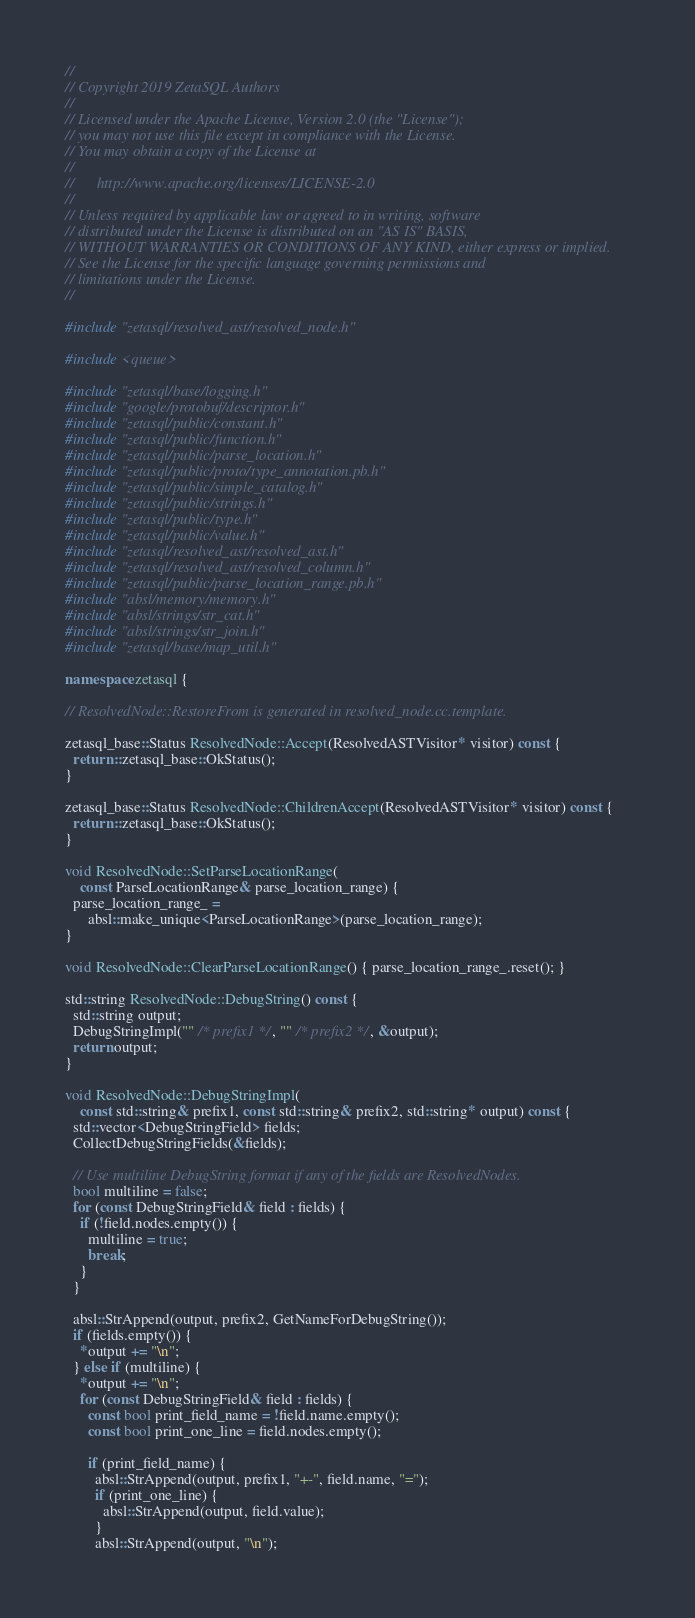<code> <loc_0><loc_0><loc_500><loc_500><_C++_>//
// Copyright 2019 ZetaSQL Authors
//
// Licensed under the Apache License, Version 2.0 (the "License");
// you may not use this file except in compliance with the License.
// You may obtain a copy of the License at
//
//      http://www.apache.org/licenses/LICENSE-2.0
//
// Unless required by applicable law or agreed to in writing, software
// distributed under the License is distributed on an "AS IS" BASIS,
// WITHOUT WARRANTIES OR CONDITIONS OF ANY KIND, either express or implied.
// See the License for the specific language governing permissions and
// limitations under the License.
//

#include "zetasql/resolved_ast/resolved_node.h"

#include <queue>

#include "zetasql/base/logging.h"
#include "google/protobuf/descriptor.h"
#include "zetasql/public/constant.h"
#include "zetasql/public/function.h"
#include "zetasql/public/parse_location.h"
#include "zetasql/public/proto/type_annotation.pb.h"
#include "zetasql/public/simple_catalog.h"
#include "zetasql/public/strings.h"
#include "zetasql/public/type.h"
#include "zetasql/public/value.h"
#include "zetasql/resolved_ast/resolved_ast.h"
#include "zetasql/resolved_ast/resolved_column.h"
#include "zetasql/public/parse_location_range.pb.h"
#include "absl/memory/memory.h"
#include "absl/strings/str_cat.h"
#include "absl/strings/str_join.h"
#include "zetasql/base/map_util.h"

namespace zetasql {

// ResolvedNode::RestoreFrom is generated in resolved_node.cc.template.

zetasql_base::Status ResolvedNode::Accept(ResolvedASTVisitor* visitor) const {
  return ::zetasql_base::OkStatus();
}

zetasql_base::Status ResolvedNode::ChildrenAccept(ResolvedASTVisitor* visitor) const {
  return ::zetasql_base::OkStatus();
}

void ResolvedNode::SetParseLocationRange(
    const ParseLocationRange& parse_location_range) {
  parse_location_range_ =
      absl::make_unique<ParseLocationRange>(parse_location_range);
}

void ResolvedNode::ClearParseLocationRange() { parse_location_range_.reset(); }

std::string ResolvedNode::DebugString() const {
  std::string output;
  DebugStringImpl("" /* prefix1 */, "" /* prefix2 */, &output);
  return output;
}

void ResolvedNode::DebugStringImpl(
    const std::string& prefix1, const std::string& prefix2, std::string* output) const {
  std::vector<DebugStringField> fields;
  CollectDebugStringFields(&fields);

  // Use multiline DebugString format if any of the fields are ResolvedNodes.
  bool multiline = false;
  for (const DebugStringField& field : fields) {
    if (!field.nodes.empty()) {
      multiline = true;
      break;
    }
  }

  absl::StrAppend(output, prefix2, GetNameForDebugString());
  if (fields.empty()) {
    *output += "\n";
  } else if (multiline) {
    *output += "\n";
    for (const DebugStringField& field : fields) {
      const bool print_field_name = !field.name.empty();
      const bool print_one_line = field.nodes.empty();

      if (print_field_name) {
        absl::StrAppend(output, prefix1, "+-", field.name, "=");
        if (print_one_line) {
          absl::StrAppend(output, field.value);
        }
        absl::StrAppend(output, "\n");</code> 